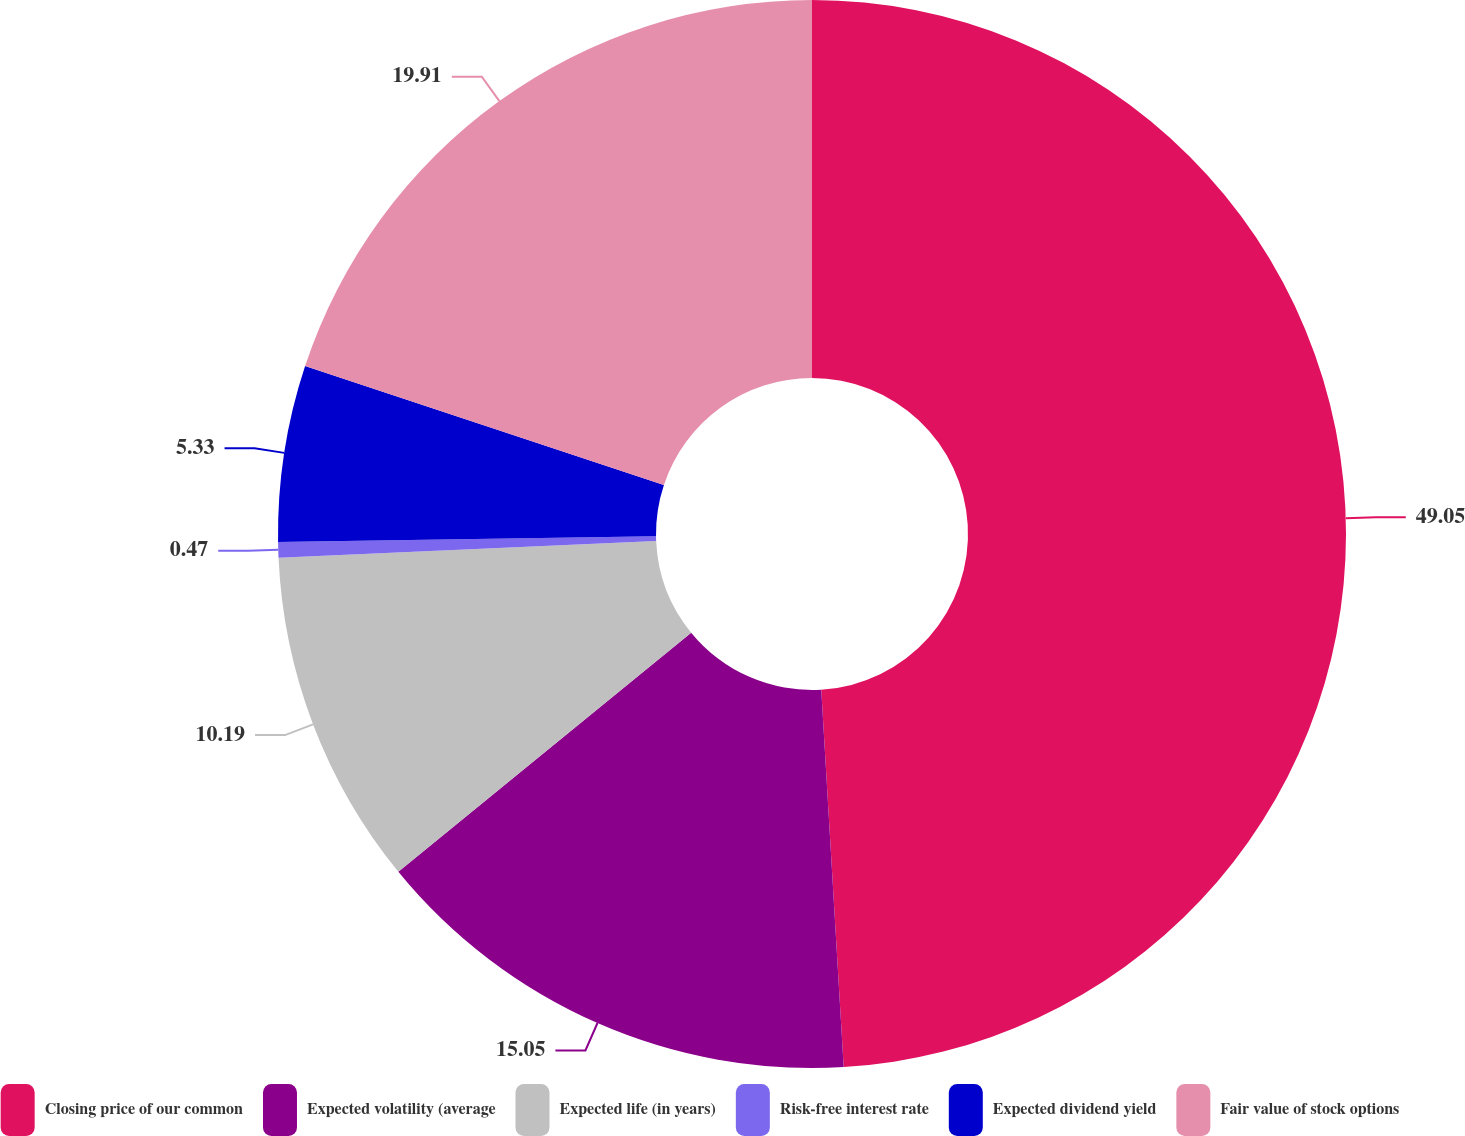Convert chart to OTSL. <chart><loc_0><loc_0><loc_500><loc_500><pie_chart><fcel>Closing price of our common<fcel>Expected volatility (average<fcel>Expected life (in years)<fcel>Risk-free interest rate<fcel>Expected dividend yield<fcel>Fair value of stock options<nl><fcel>49.06%<fcel>15.05%<fcel>10.19%<fcel>0.47%<fcel>5.33%<fcel>19.91%<nl></chart> 